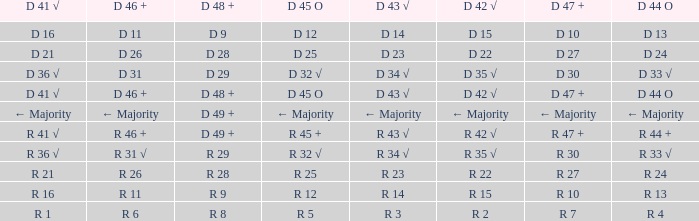What is the value of D 42 √, when the value of D 45 O is d 32 √? D 35 √. 